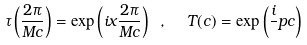Convert formula to latex. <formula><loc_0><loc_0><loc_500><loc_500>\tau \left ( \frac { 2 \pi } { M c } \right ) = \exp \left ( i x \frac { 2 \pi } { M c } \right ) \ , \ \ T ( c ) = \exp \left ( \frac { i } { } p c \right )</formula> 